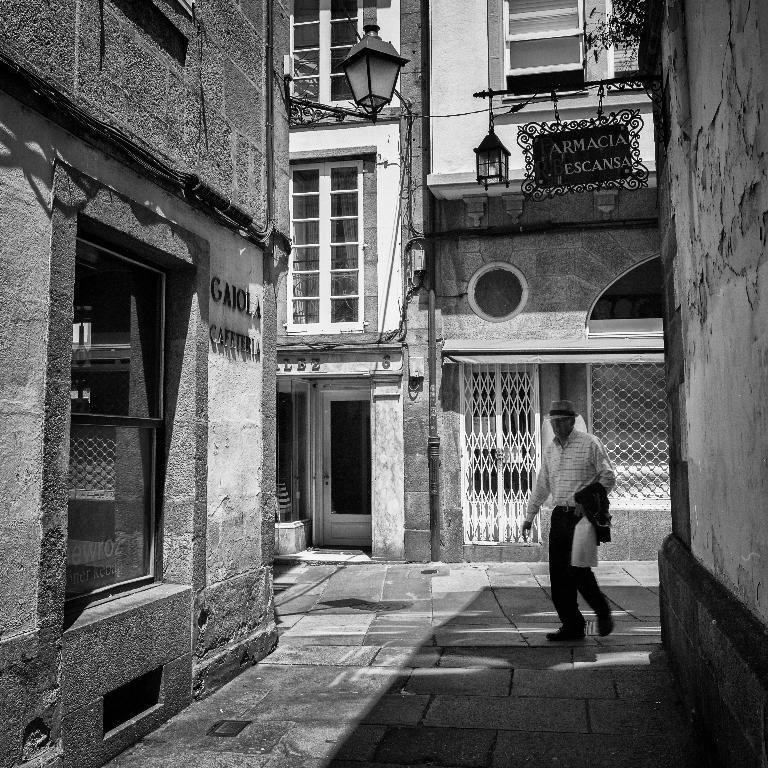Please provide a concise description of this image. In this image there is a person walking, there is a person holding an object, there is a building truncated towards the right of the image, there is a building truncated towards the left of the image, there are windows, there is the door, there are lights, there is board, there is text on the board. 